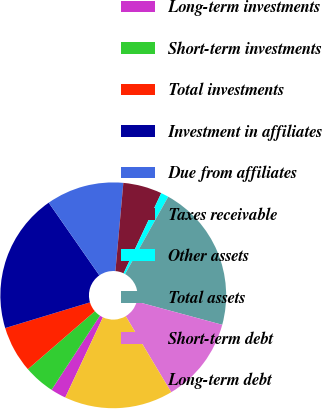Convert chart. <chart><loc_0><loc_0><loc_500><loc_500><pie_chart><fcel>Long-term investments<fcel>Short-term investments<fcel>Total investments<fcel>Investment in affiliates<fcel>Due from affiliates<fcel>Taxes receivable<fcel>Other assets<fcel>Total assets<fcel>Short-term debt<fcel>Long-term debt<nl><fcel>2.22%<fcel>4.44%<fcel>6.67%<fcel>20.0%<fcel>11.11%<fcel>5.56%<fcel>1.11%<fcel>21.11%<fcel>12.22%<fcel>15.56%<nl></chart> 